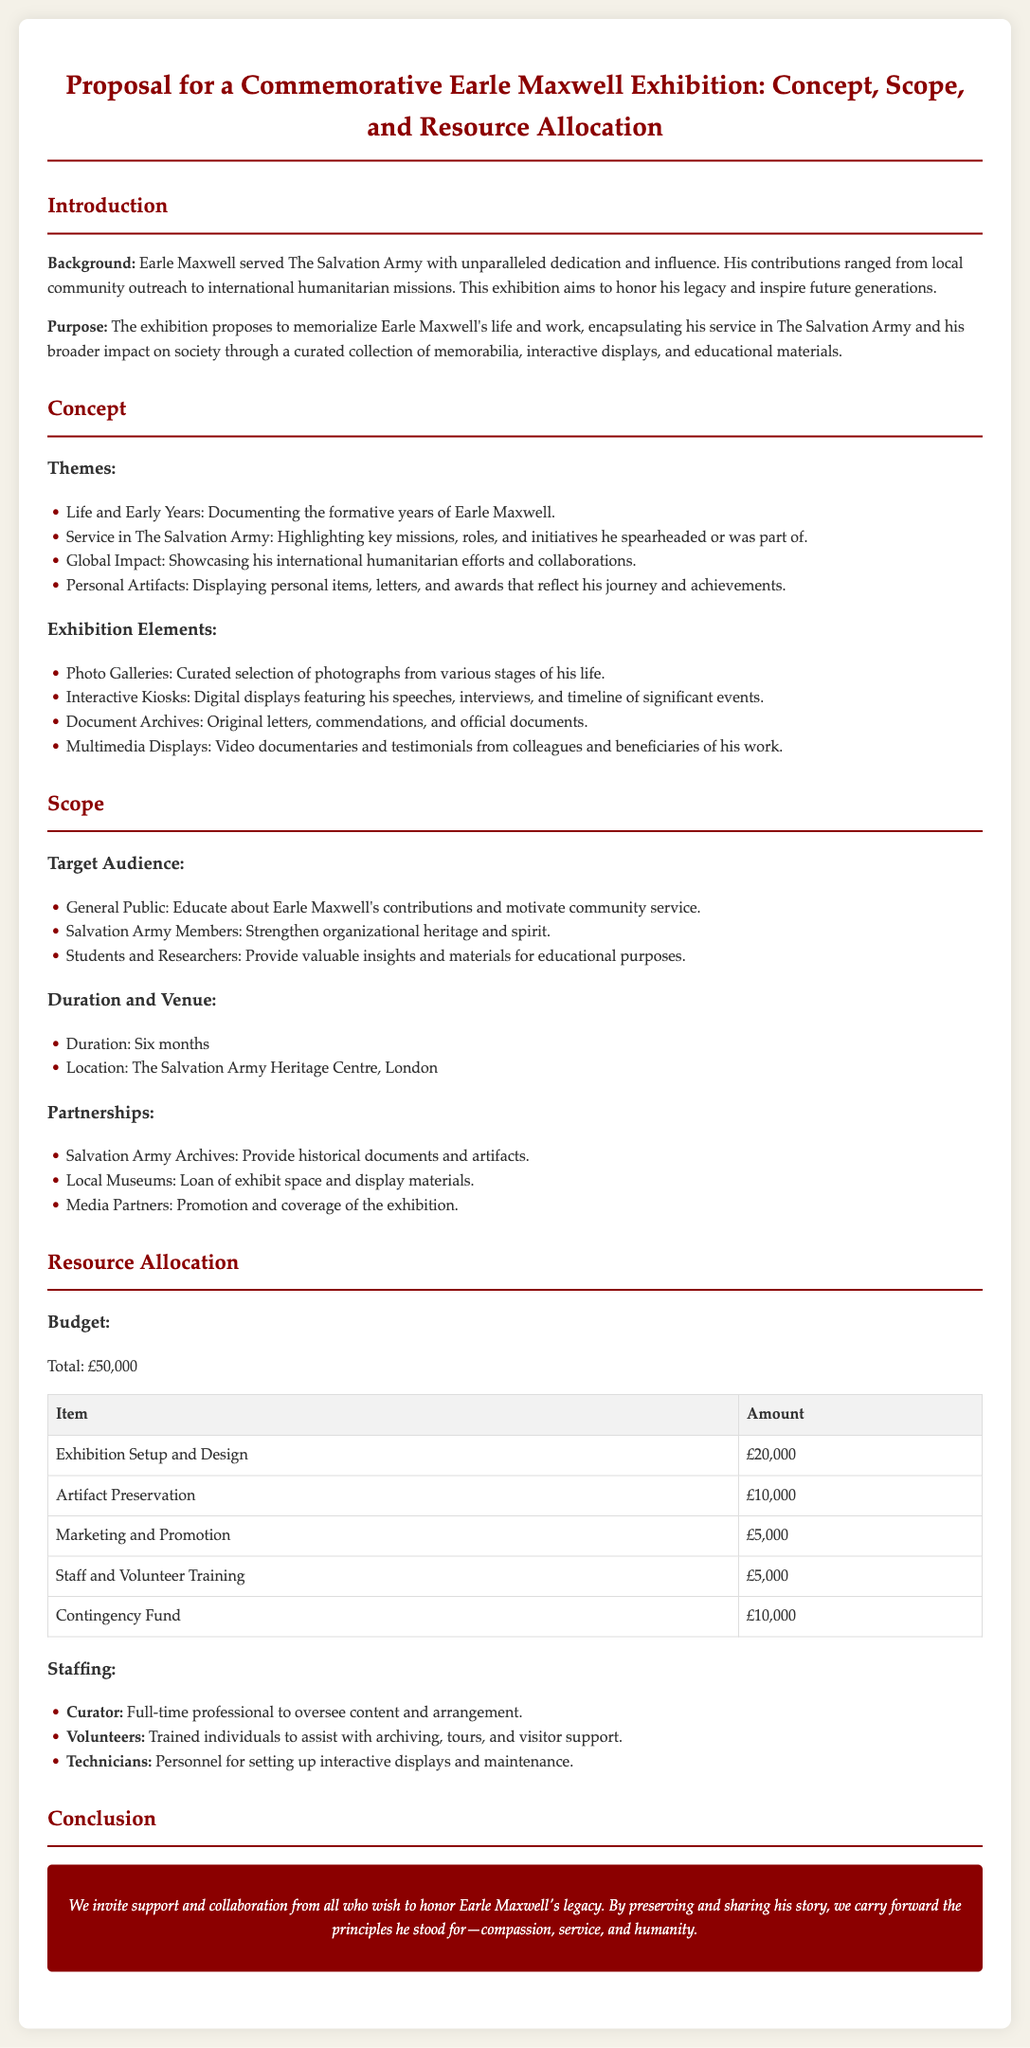What is the total budget for the exhibition? The total budget is clearly mentioned in the document.
Answer: £50,000 Where will the exhibition take place? The location of the exhibition is specified in the Scope section.
Answer: The Salvation Army Heritage Centre, London Who was Earle Maxwell? His background is discussed in the Introduction section, highlighting his contributions.
Answer: A dedicated servant of The Salvation Army What are the themes of the exhibition? The themes section lists several key areas to be highlighted in the exhibition.
Answer: Life and Early Years, Service in The Salvation Army, Global Impact, Personal Artifacts How long will the exhibition last? The duration of the exhibition is stated under the Scope section.
Answer: Six months What is one of the exhibition elements? A list of exhibition elements is provided; one can be directly quoted.
Answer: Photo Galleries What is the purpose of the exhibition? The purpose is clearly articulated in the Introduction section.
Answer: To memorialize Earle Maxwell's life and work Who will assist with archiving and visitor support? Staffing mentions volunteers assisting with various activities.
Answer: Trained individuals What is the budget allocation for marketing and promotion? The budget table specifies amounts for different budget items.
Answer: £5,000 